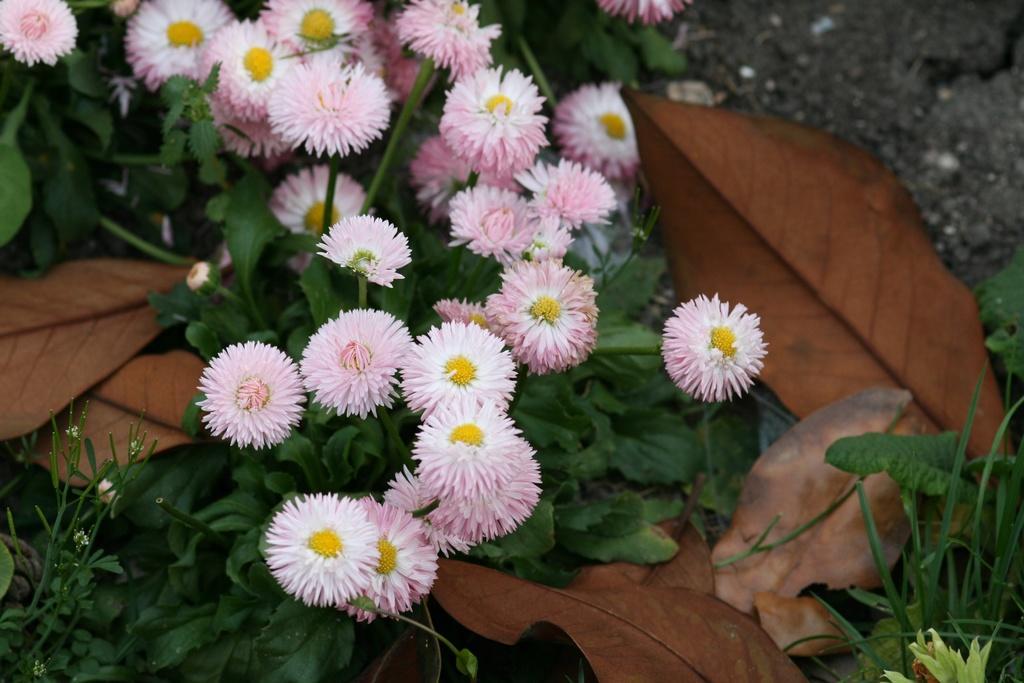Could you give a brief overview of what you see in this image? In this image, we can see plants with leaves, stems and flowers. Here we can see few dry leaves. 